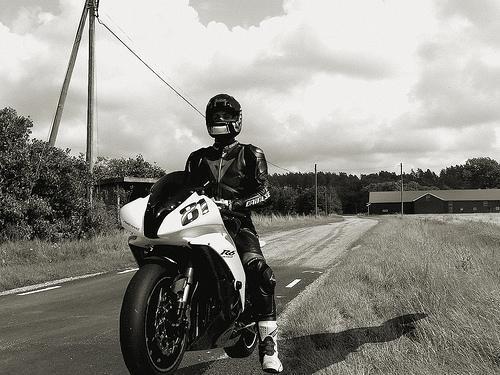How many people are on the motorcycle?
Give a very brief answer. 1. 